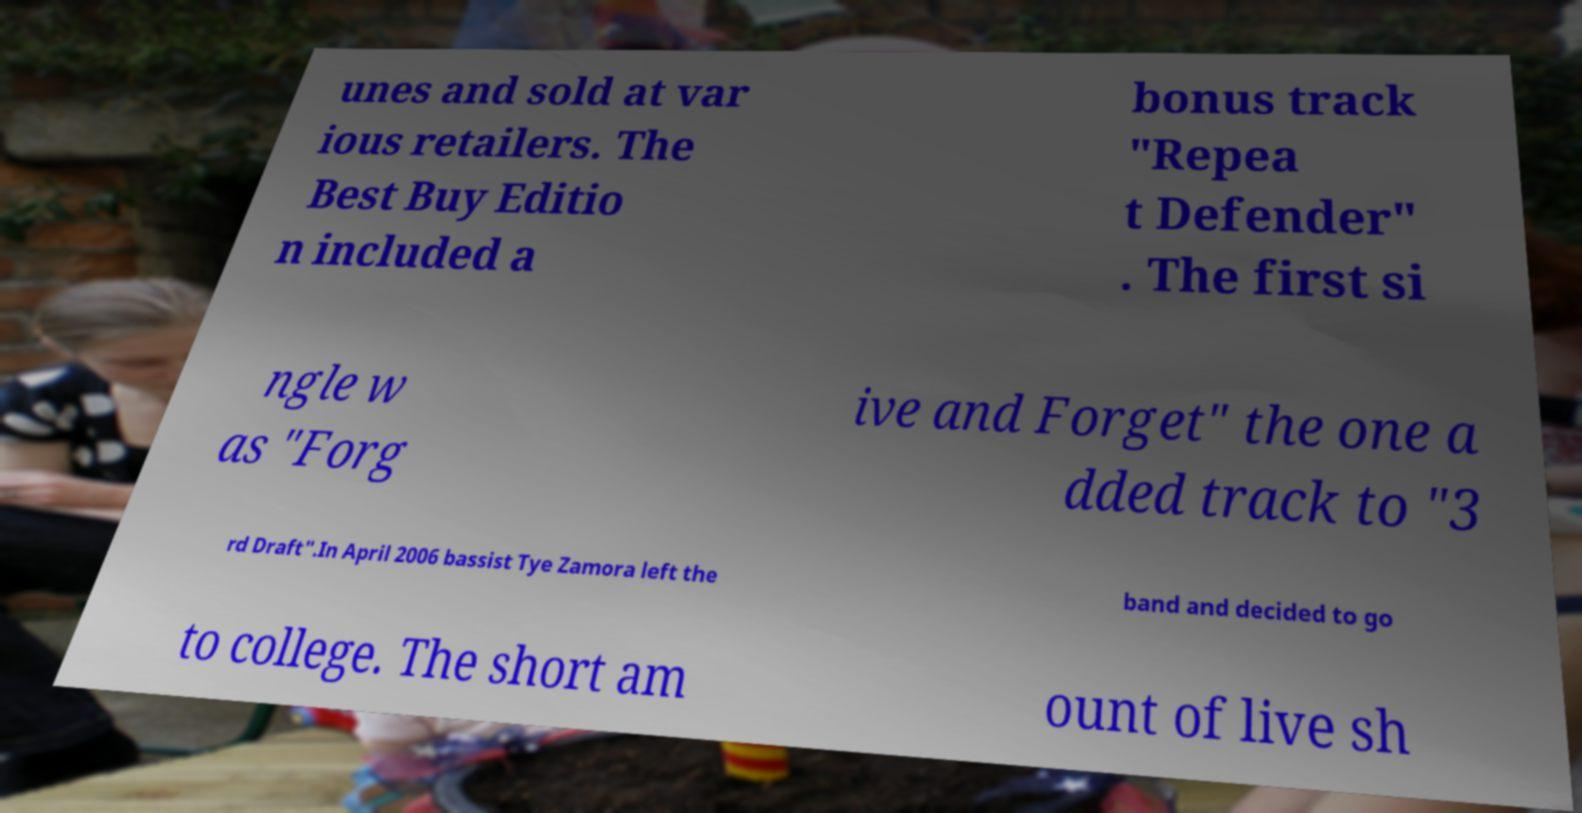What messages or text are displayed in this image? I need them in a readable, typed format. unes and sold at var ious retailers. The Best Buy Editio n included a bonus track "Repea t Defender" . The first si ngle w as "Forg ive and Forget" the one a dded track to "3 rd Draft".In April 2006 bassist Tye Zamora left the band and decided to go to college. The short am ount of live sh 